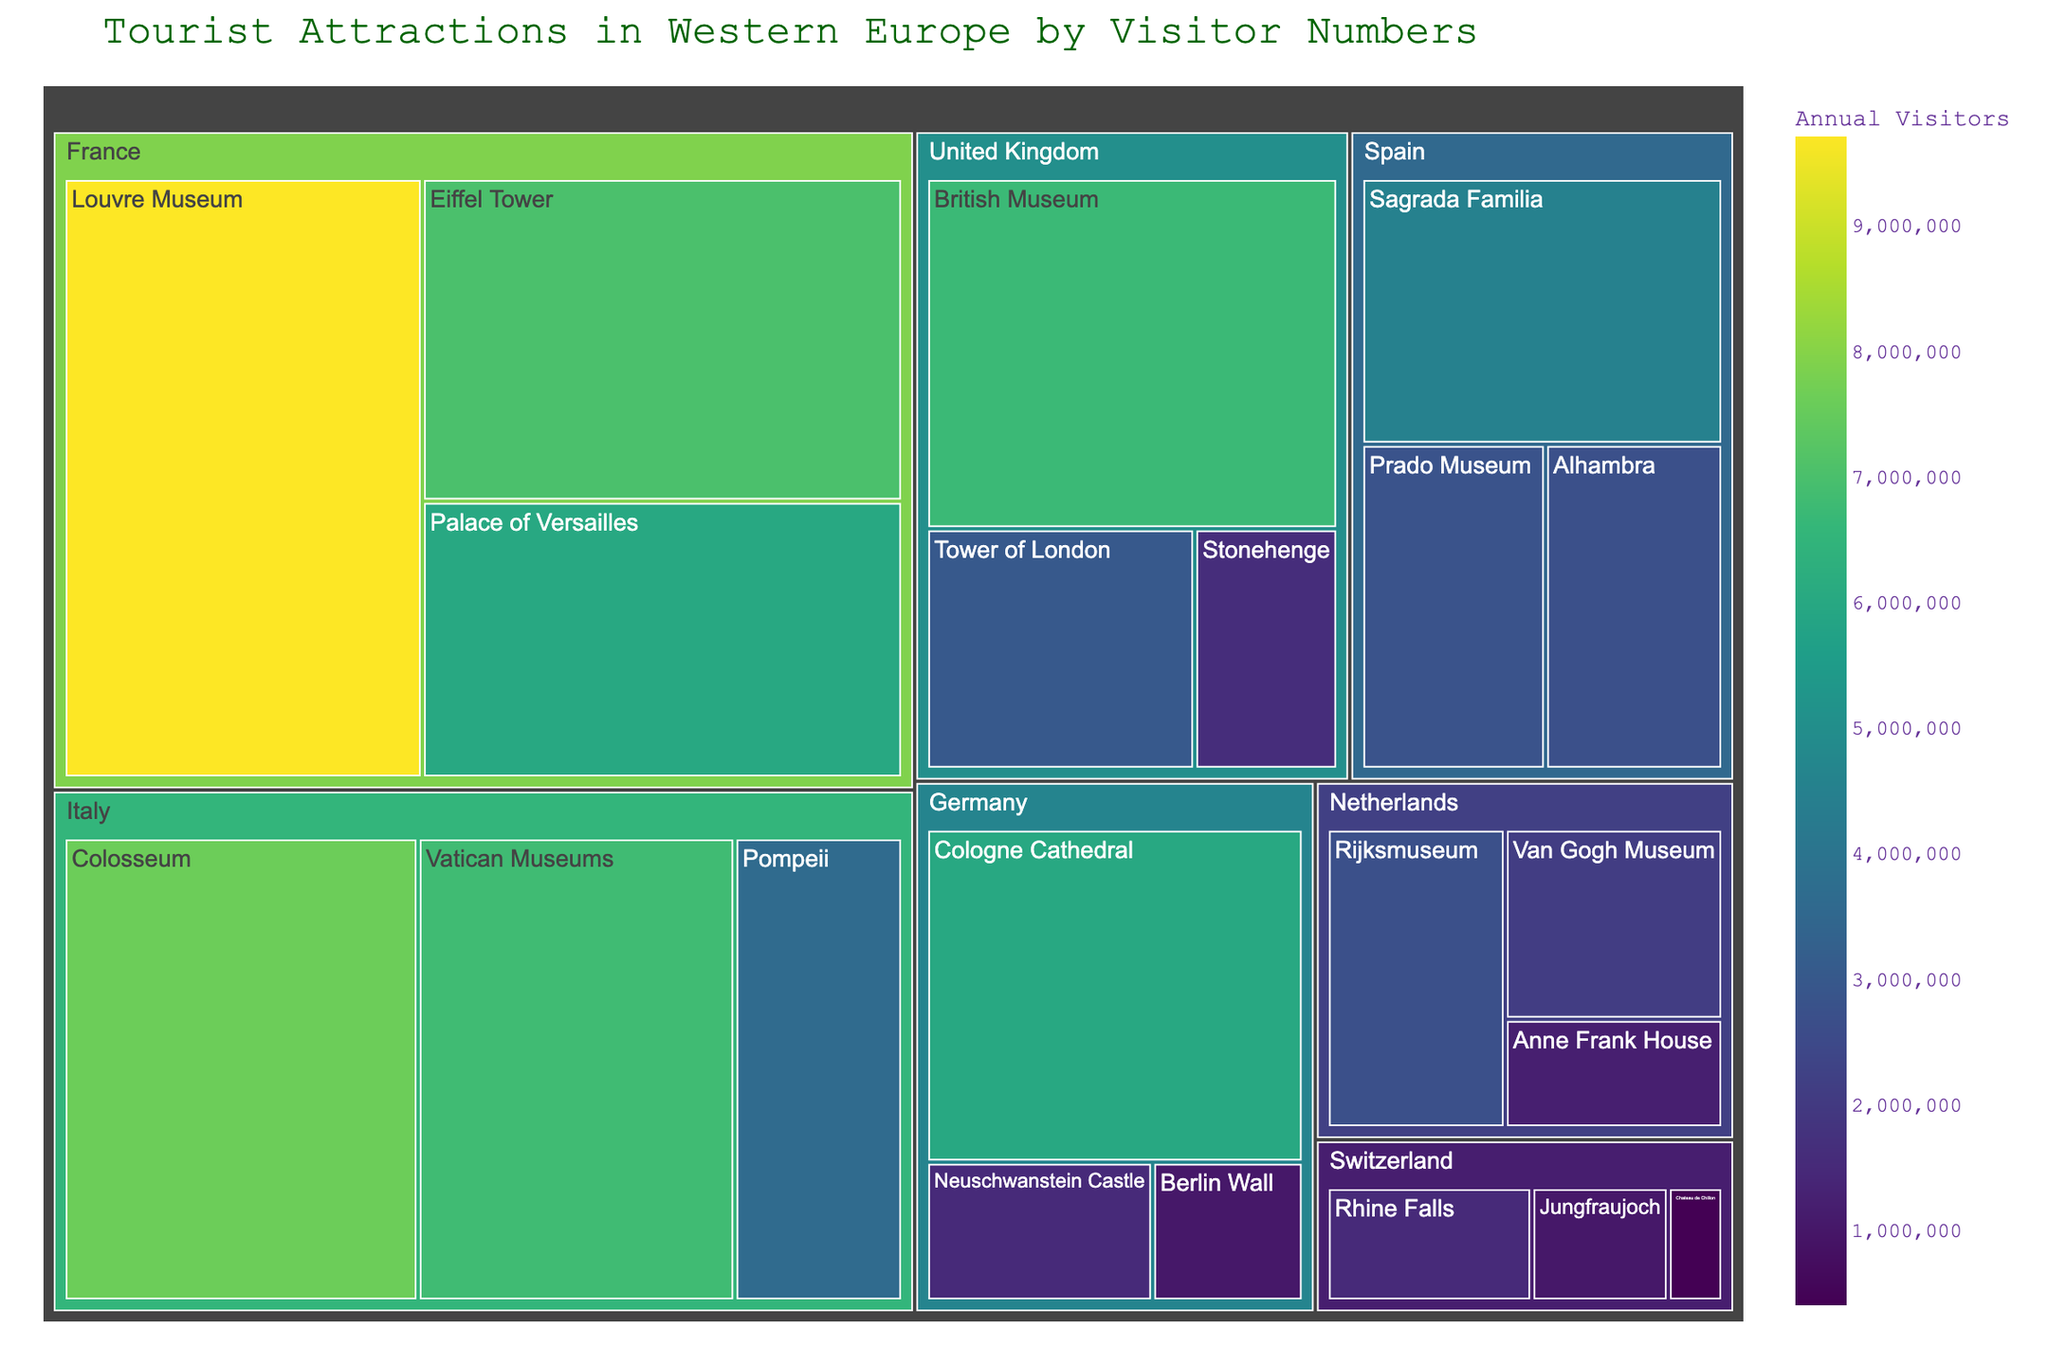What is the title of the figure? The title is usually displayed at the top of the figure. Looking at the figure, the title reads 'Tourist Attractions in Western Europe by Visitor Numbers'.
Answer: Tourist Attractions in Western Europe by Visitor Numbers Which country has the attraction with the highest number of visitors? Identify the block with the largest area or most intense color and then check the country associated with it. The largest block corresponds to the Louvre Museum in France with 9,700,000 visitors.
Answer: France Which country has the least number of tourist attractions listed? Count the number of attractions for each country. Switzerland has only three attractions listed: Chateau de Chillon, Jungfraujoch, and Rhine Falls.
Answer: Switzerland How many attractions in Italy have more visitors than the Stonehenge in the United Kingdom? Identify the visitor number for Stonehenge (1,600,000) and compare it with each of Italy's attractions' visitor counts. The Colosseum (7,600,000), Vatican Museums (6,800,000), and Pompeii (3,600,000) all exceed this count. Hence, the answer is 3 attractions.
Answer: 3 What is the total number of visitors for the attractions in France? Sum the number of visitors for each attraction in France: Louvre Museum (9,700,000) + Eiffel Tower (7,000,000) + Palace of Versailles (6,000,000). The total is 22,700,000.
Answer: 22,700,000 Which attraction in Germany receives the highest number of visitors? Identify the attraction within Germany with the highest visitor count. The Cologne Cathedral has the highest number of visitors at 6,000,000.
Answer: Cologne Cathedral Compare the visitors of the British Museum and the Vatican Museums. Which one has more? Locate both attractions and compare their numbers. The British Museum has 6,700,000 visitors while the Vatican Museums have 6,800,000 visitors. The Vatican Museums have more visitors.
Answer: Vatican Museums Which attraction in Spain attracts the least visitors? Identify the attraction in Spain with the lowest visitor count. The Alhambra attracts 2,700,000 visitors, which is less than the other Spanish attractions listed (Sagrada Familia and Prado Museum).
Answer: Alhambra How many more visitors does the Louvre Museum have compared to the Eiffel Tower? Subtract the number of visitors to the Eiffel Tower (7,000,000) from those to the Louvre Museum (9,700,000). The difference is 2,700,000.
Answer: 2,700,000 What is the average number of visitors for the attractions in the Netherlands? Sum the visitor counts for the Netherlands' attractions and divide by the number of attractions. The total visitors are (Anne Frank House 1,200,000) + (Van Gogh Museum 2,100,000) + (Rijksmuseum 2,700,000) = 6,000,000. The number of attractions is 3, so the average number is 6,000,000 / 3 = 2,000,000.
Answer: 2,000,000 